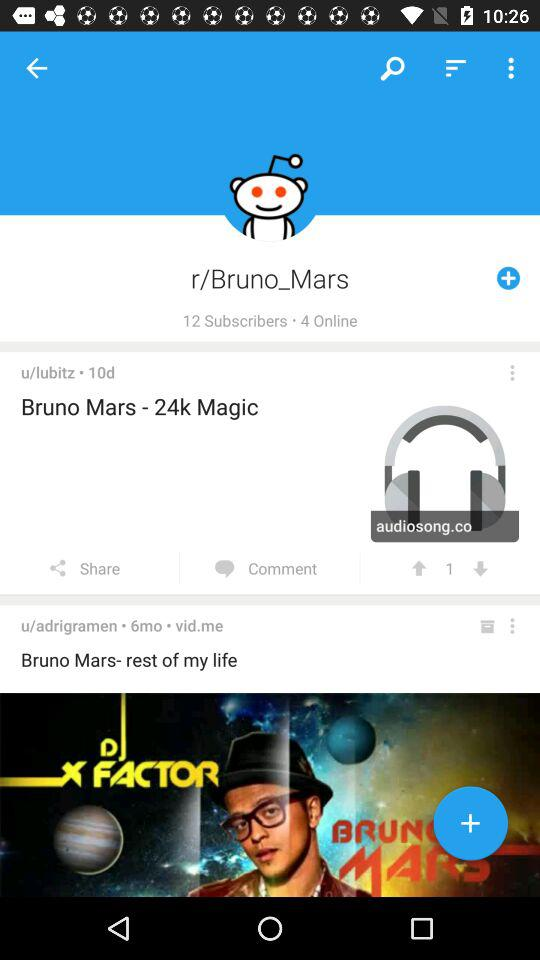How many subscribers are there? There are 12 subscribers. 